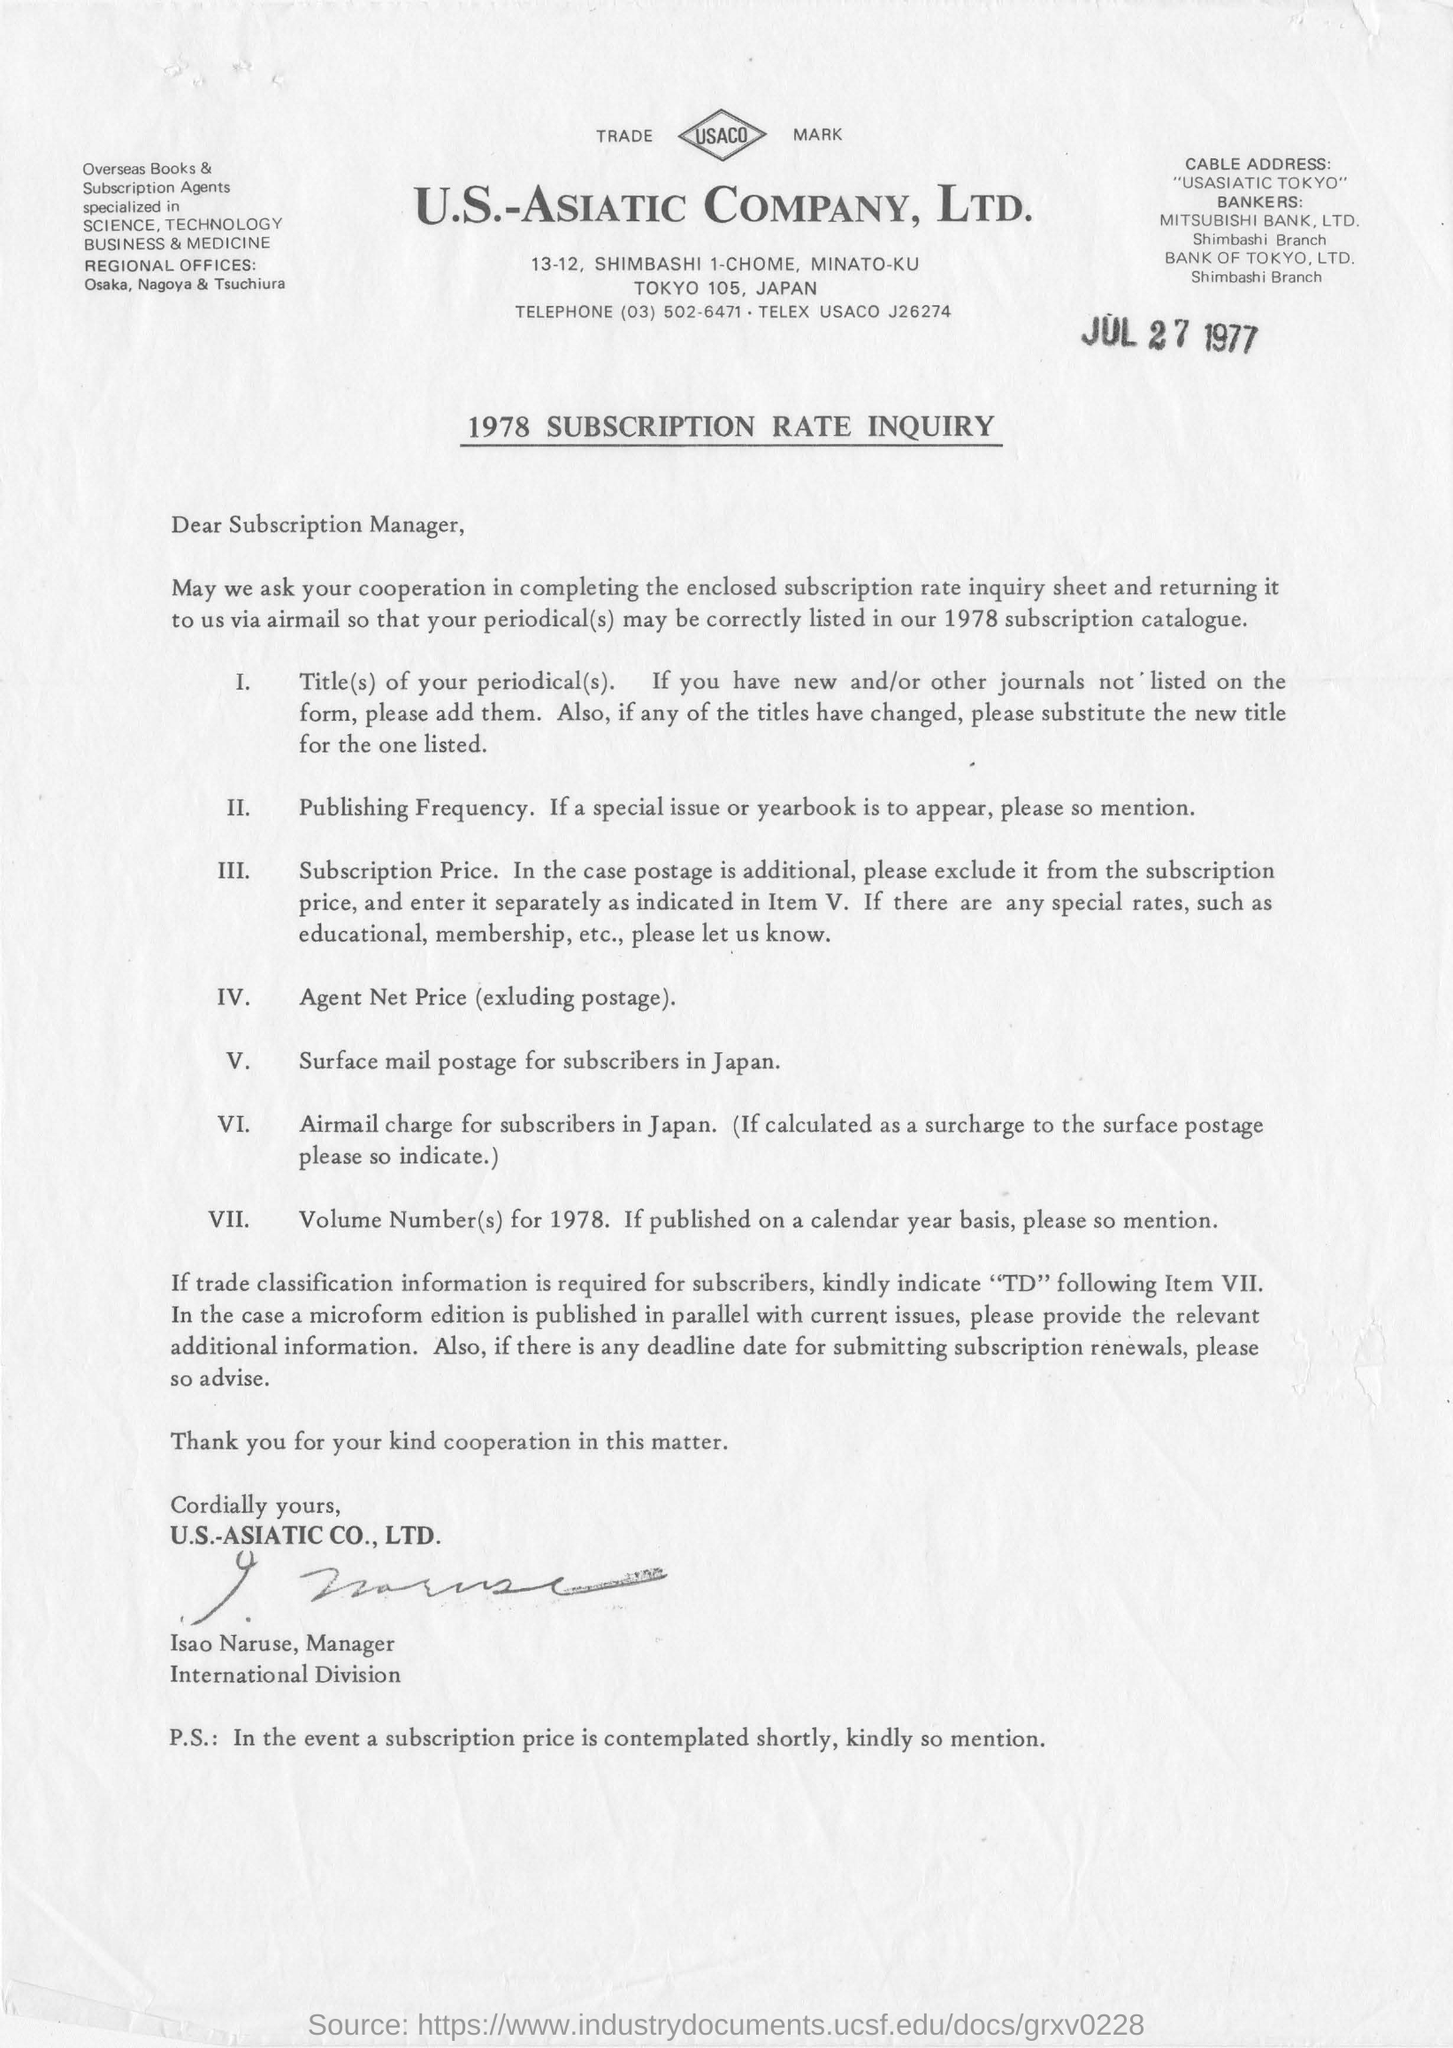Mention a couple of crucial points in this snapshot. U.S.-ASIATIC COMPANY, Ltd. is the name of the company. The cable address "USASIATIC TOKYO" contains information about a specific communication. The person to whom this letter was written is the Subscription Manager. The telephone number of the given company is (03) 502-6471. The letter has been signed by Isao Naruse, the Manager. 